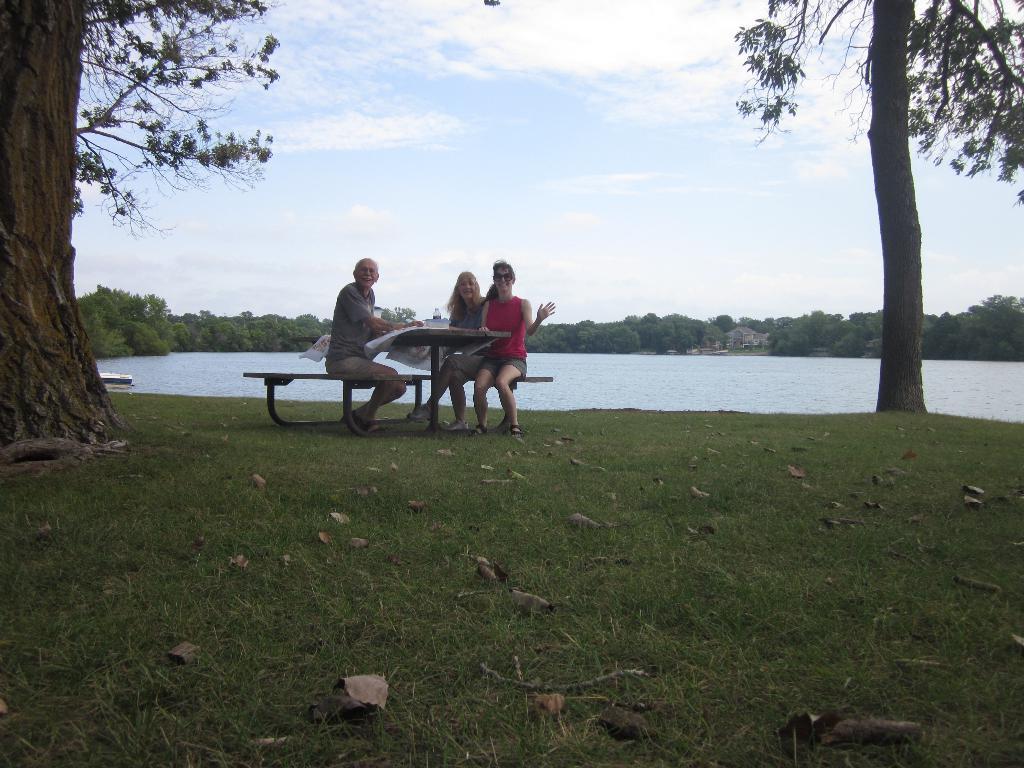Can you describe this image briefly? In this image we can see a group of people are sitting on the chair and smiling, and in front here is the table, and here is the tree, and here is the water, and here is the grass, and at above here the sky is cloudy. 